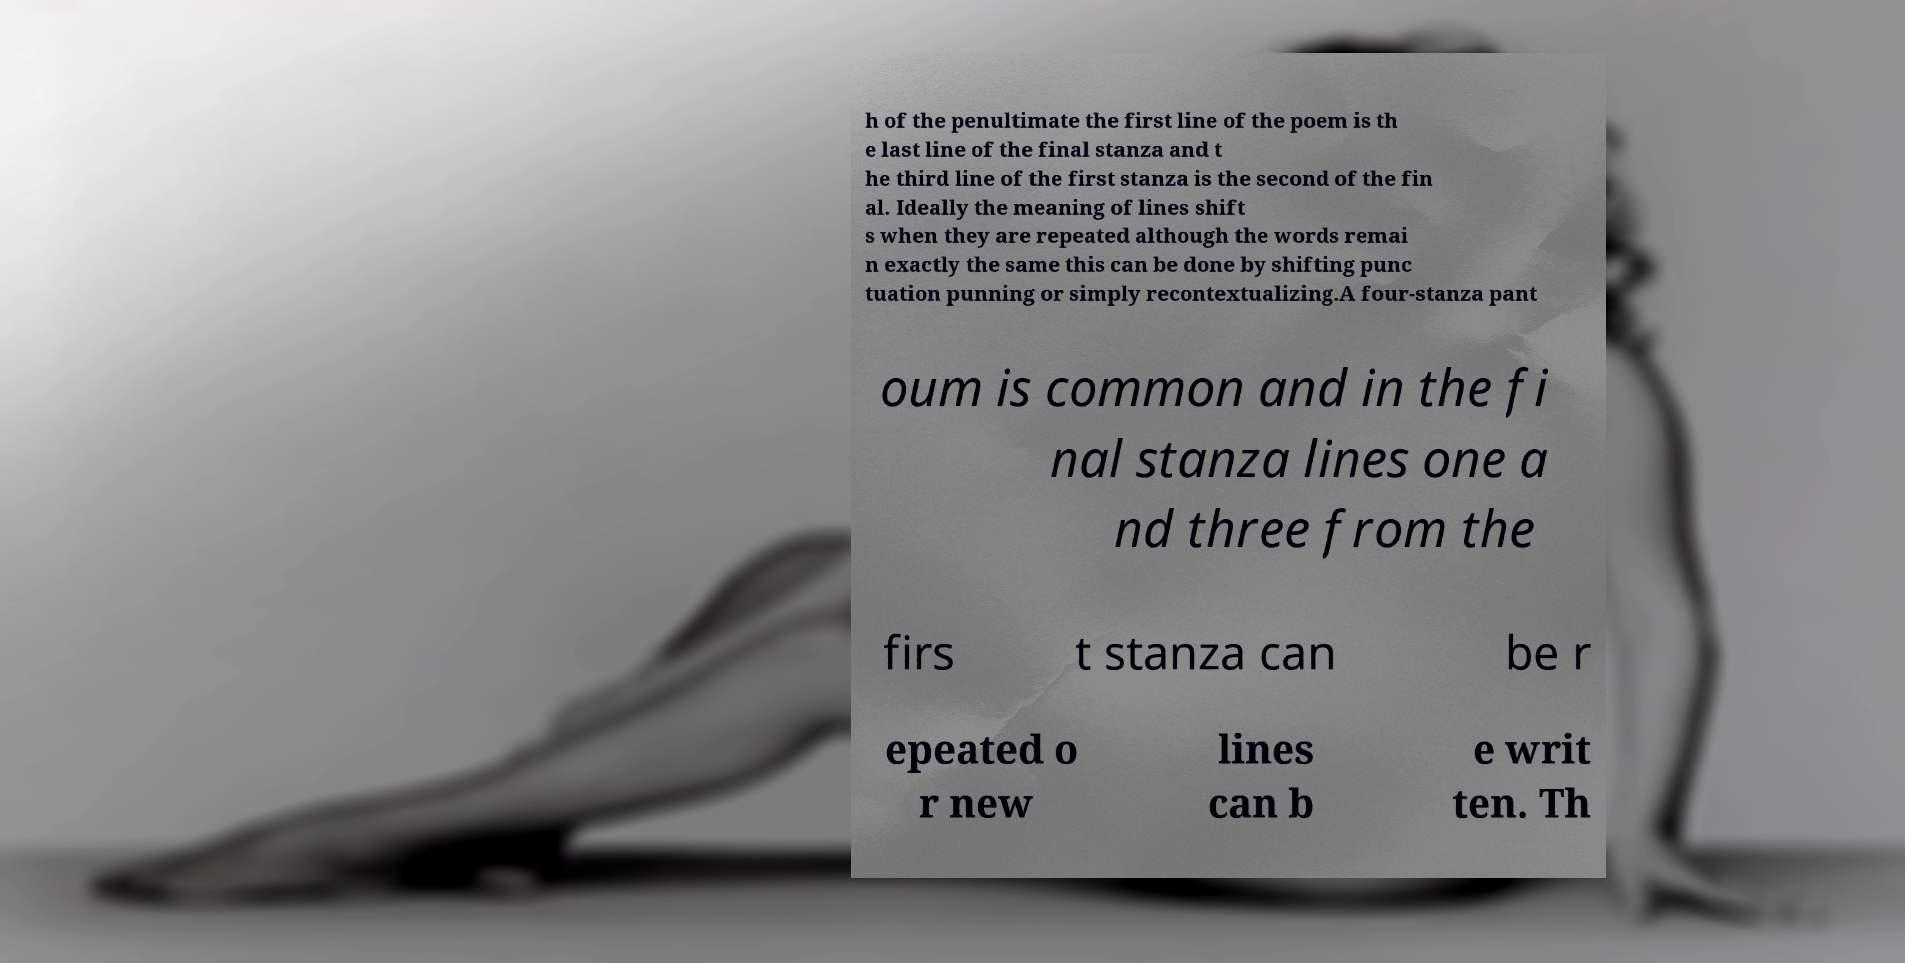Could you assist in decoding the text presented in this image and type it out clearly? h of the penultimate the first line of the poem is th e last line of the final stanza and t he third line of the first stanza is the second of the fin al. Ideally the meaning of lines shift s when they are repeated although the words remai n exactly the same this can be done by shifting punc tuation punning or simply recontextualizing.A four-stanza pant oum is common and in the fi nal stanza lines one a nd three from the firs t stanza can be r epeated o r new lines can b e writ ten. Th 